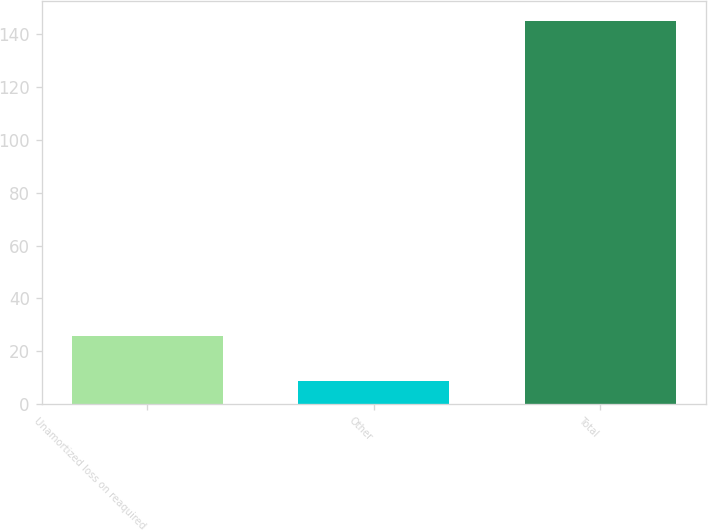Convert chart. <chart><loc_0><loc_0><loc_500><loc_500><bar_chart><fcel>Unamortized loss on reaquired<fcel>Other<fcel>Total<nl><fcel>25.8<fcel>8.6<fcel>145.2<nl></chart> 